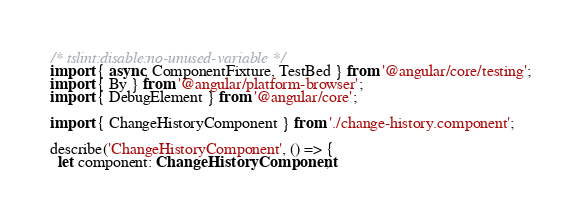Convert code to text. <code><loc_0><loc_0><loc_500><loc_500><_TypeScript_>/* tslint:disable:no-unused-variable */
import { async, ComponentFixture, TestBed } from '@angular/core/testing';
import { By } from '@angular/platform-browser';
import { DebugElement } from '@angular/core';

import { ChangeHistoryComponent } from './change-history.component';

describe('ChangeHistoryComponent', () => {
  let component: ChangeHistoryComponent;</code> 